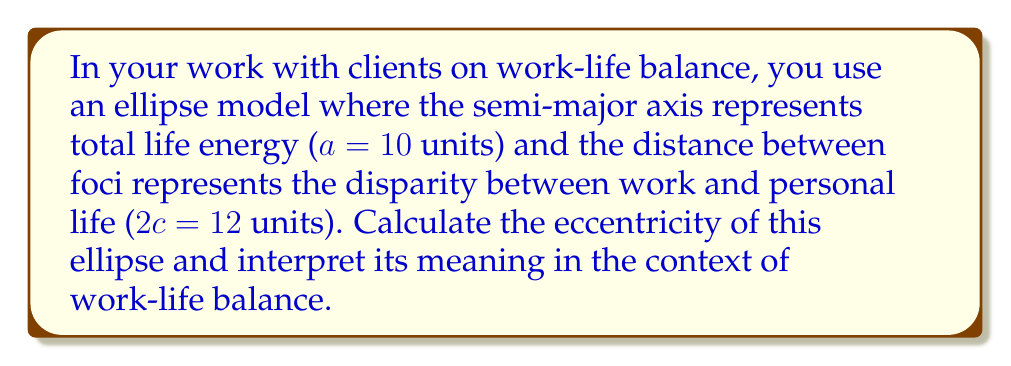Can you solve this math problem? Let's approach this step-by-step:

1) The eccentricity of an ellipse is given by the formula:

   $$ e = \frac{c}{a} $$

   where $c$ is the distance from the center to a focus, and $a$ is the length of the semi-major axis.

2) We're given that $a = 10$ units and $2c = 12$ units.

3) First, we need to find $c$:
   $$ 2c = 12 $$
   $$ c = 6 $$

4) Now we can calculate the eccentricity:
   $$ e = \frac{c}{a} = \frac{6}{10} = 0.6 $$

5) To interpret this result:
   - Eccentricity ranges from 0 (a circle, perfect balance) to 1 (a parabola, extreme imbalance).
   - An eccentricity of 0.6 suggests a moderate imbalance between work and personal life.
   - This ellipse is noticeably elongated, indicating that the client's energy is not evenly distributed between work and personal life.

6) In the context of work-life balance:
   - The client might benefit from strategies to redistribute their energy more evenly.
   - There's room for improvement in achieving a more circular (balanced) life model.
   - This visual representation could be a powerful tool for the client to understand their current state and set goals for better balance.

[asy]
import geometry;

unitsize(10mm);

real a = 10;
real c = 6;
real b = sqrt(a^2 - c^2);

draw(ellipse((0,0), a, b), rgb(0,0,0)+1);
draw((-a,0)--(a,0), dashed);
draw((0,-b)--(0,b), dashed);
dot((-c,0));
dot((c,0));
label("F", (-c,0), SW);
label("F", (c,0), SE);

label("2a", (0,-b-1), S);
draw((-a,-b-0.5)--(a,-b-0.5), Arrows);

label("2c", (0,b+1), N);
draw((-c,b+0.5)--(c,b+0.5), Arrows);
[/asy]
Answer: The eccentricity of the ellipse is 0.6, indicating a moderate imbalance between work and personal life. 